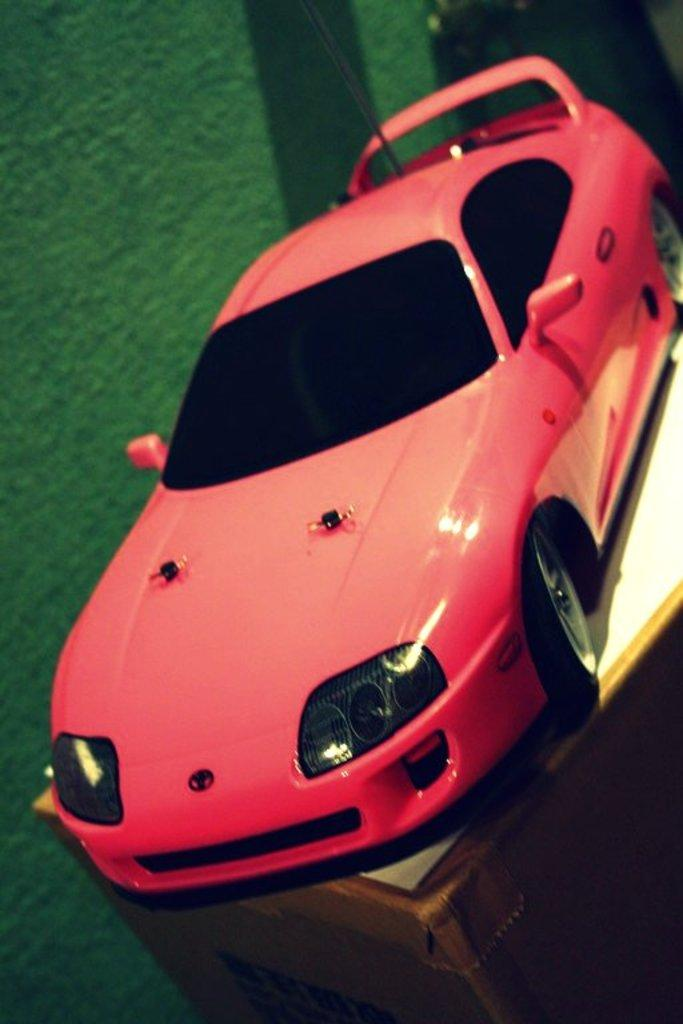What type of toy is in the image? There is a toy car in the image. What colors are used for the toy car? The toy car is red and black in color. On what surface is the toy car placed? The toy car is placed on a wooden surface. What color is the background of the image? The background of the image is green. What language is the toy car speaking in the image? Toys do not speak, so there is no language present in the image. What type of animal can be seen interacting with the toy car in the image? There are no animals present in the image; it only features a toy car on a wooden surface with a green background. 